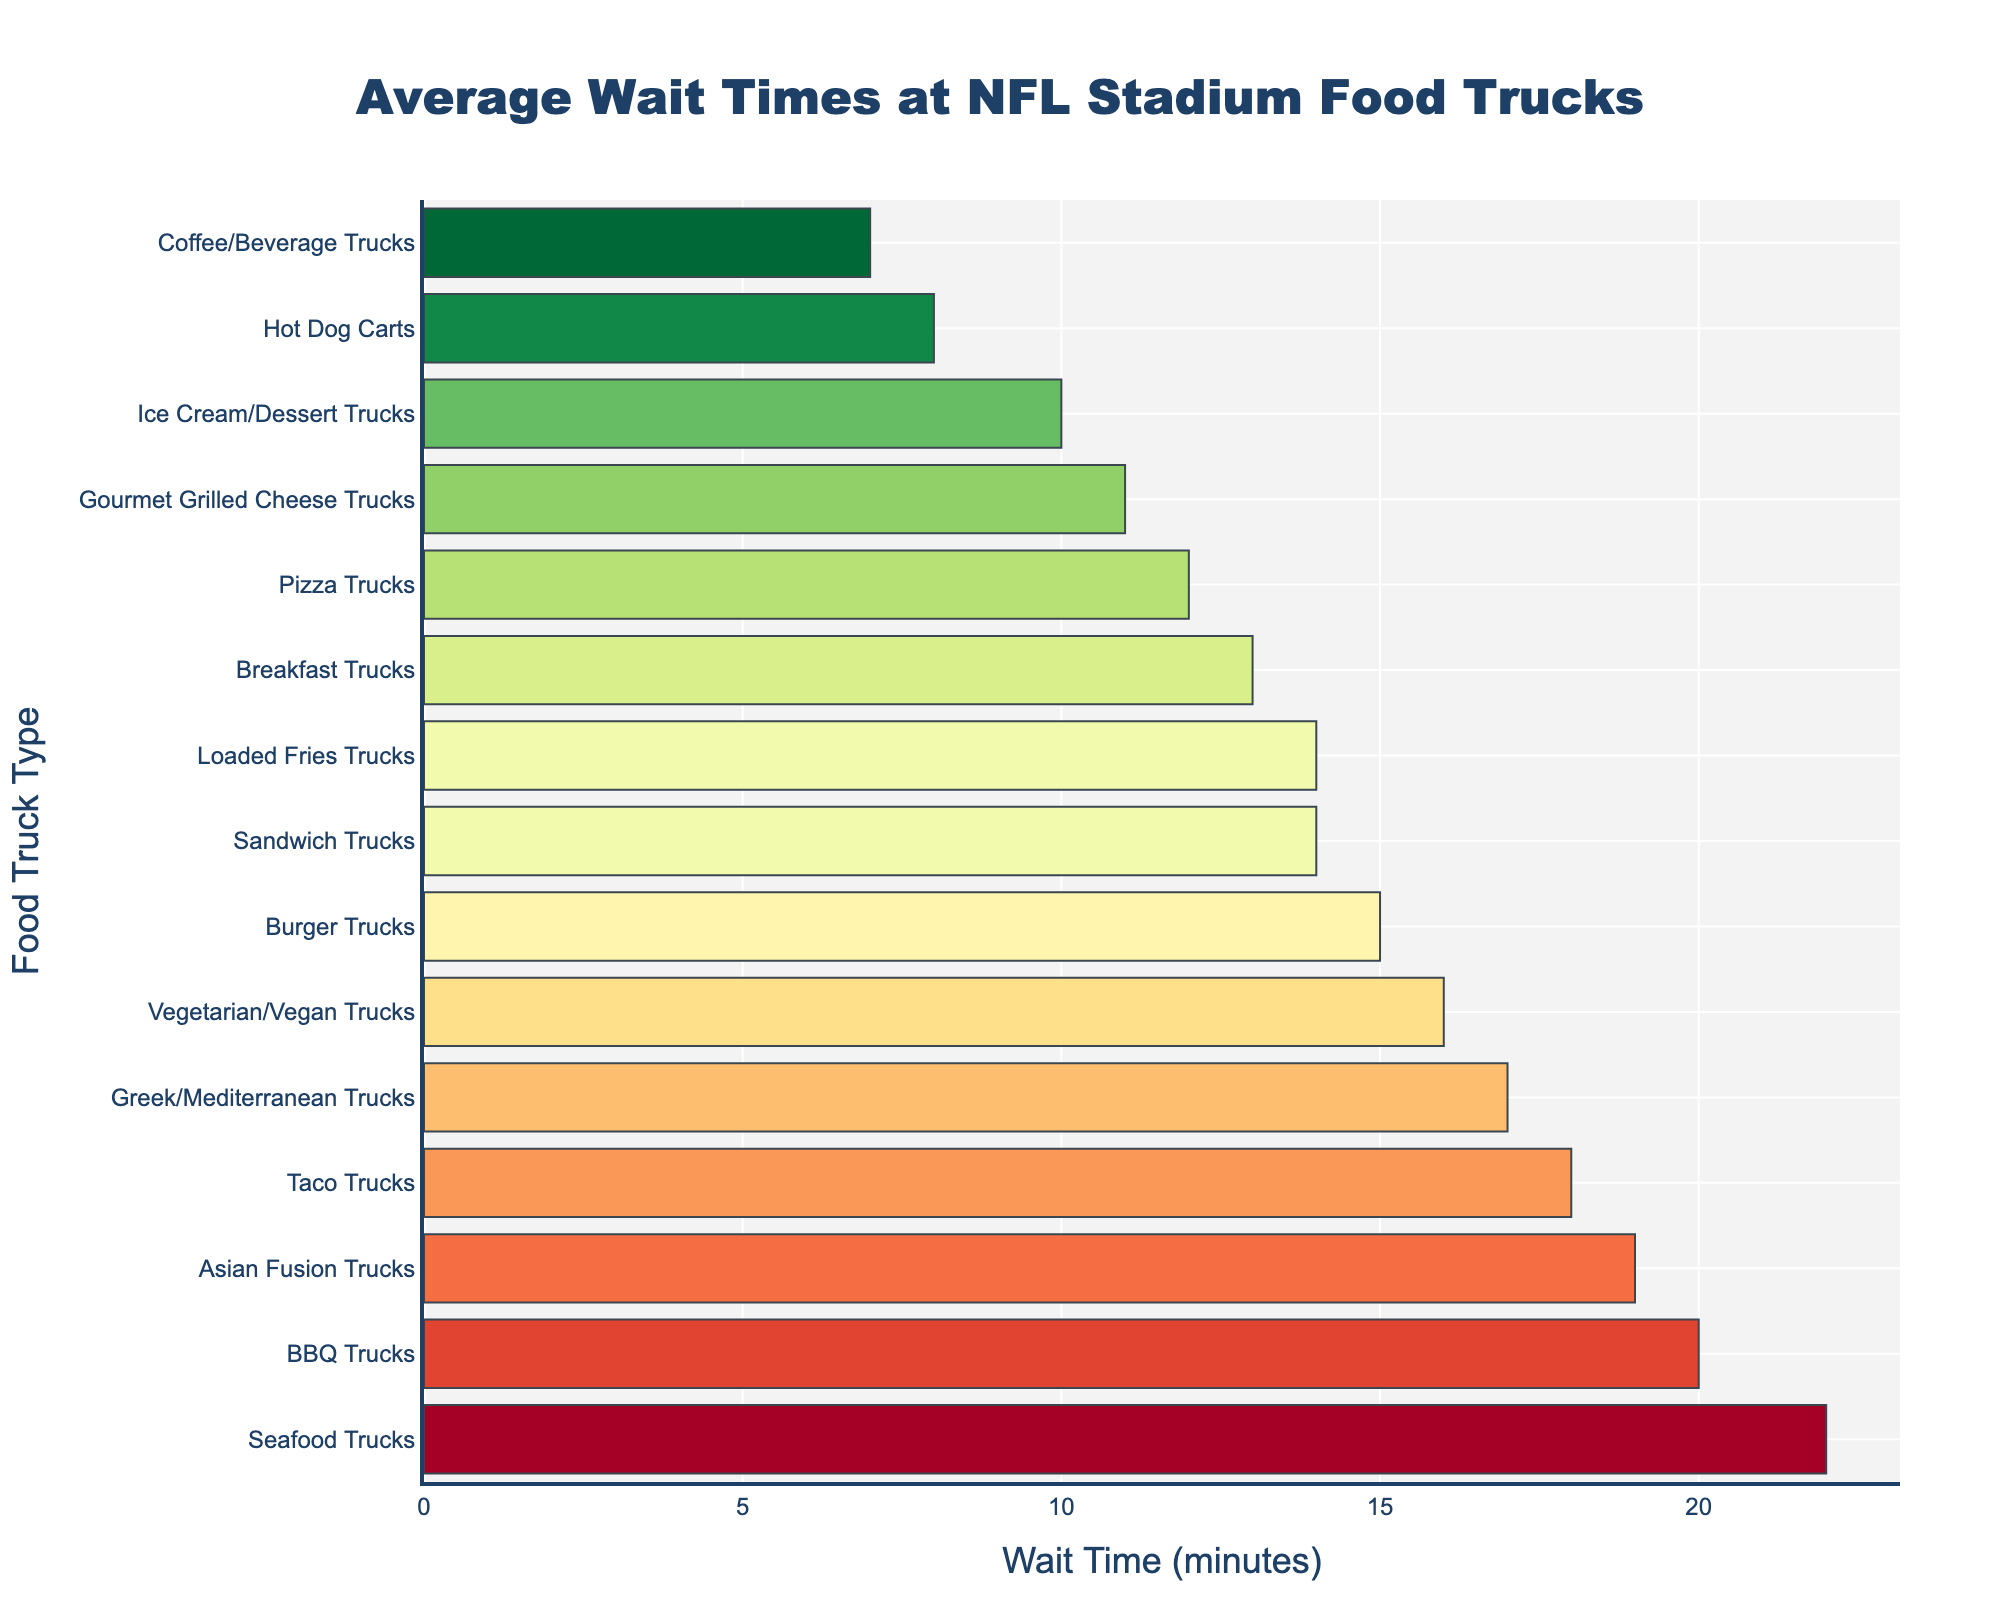Which food truck has the longest average wait time? The bar chart shows the average wait times for different food trucks, with seafood trucks having the longest bar.
Answer: Seafood Trucks How does the wait time for Burger Trucks compare to Pizza Trucks? The wait time for Burger Trucks is 15 minutes, and for Pizza Trucks, it is 12 minutes. So, Burger Trucks have a longer wait time.
Answer: Burger Trucks have a longer wait time Which food truck type has the shortest average wait time? The bar chart shows that Coffee/Beverage Trucks have the shortest bar, representing the shortest wait time.
Answer: Coffee/Beverage Trucks What is the difference in average wait time between Taco Trucks and Hot Dog Carts? Taco Trucks have an 18-minute wait time, while Hot Dog Carts have 8 minutes. The difference is 18 - 8 = 10 minutes.
Answer: 10 minutes What is the average wait time for all food trucks combined? Sum all average wait times (15+12+18+20+8+14+22+16+19+17+10+7+13+11+14) = 216 minutes. Divide by the number of food trucks (15). The average wait time is 216/15 = 14.4 minutes.
Answer: 14.4 minutes Is the wait time for Greek/Mediterranean Trucks longer or shorter than for Asian Fusion Trucks? The Greek/Mediterranean Trucks' wait time is 17 minutes, while the Asian Fusion Trucks' wait time is 19 minutes. Greek/Mediterranean Trucks have a shorter wait time.
Answer: Shorter Which food trucks have a wait time less than 10 minutes? The bar chart shows Coffee/Beverage Trucks (7 minutes) and Hot Dog Carts (8 minutes) with average wait times less than 10 minutes.
Answer: Coffee/Beverage Trucks, Hot Dog Carts What is the combined wait time for Breakfast Trucks and Gourmet Grilled Cheese Trucks? The wait time for Breakfast Trucks is 13 minutes, and for Gourmet Grilled Cheese Trucks, it is 11 minutes. So, 13 + 11 = 24 minutes.
Answer: 24 minutes List the food trucks with a wait time longer than 15 minutes. The bar chart shows seafood trucks, BBQ trucks, Asian Fusion trucks, Greek/Mediterranean trucks, and Vegetarian/Vegan trucks with wait times longer than 15 minutes.
Answer: Seafood, BBQ, Asian Fusion, Greek/Mediterranean, Vegetarian/Vegan How does the wait time for Loaded Fries Trucks compare to Sandwich Trucks? Both Loaded Fries Trucks and Sandwich Trucks have a wait time of 14 minutes each; thus, their wait times are the same.
Answer: Same 